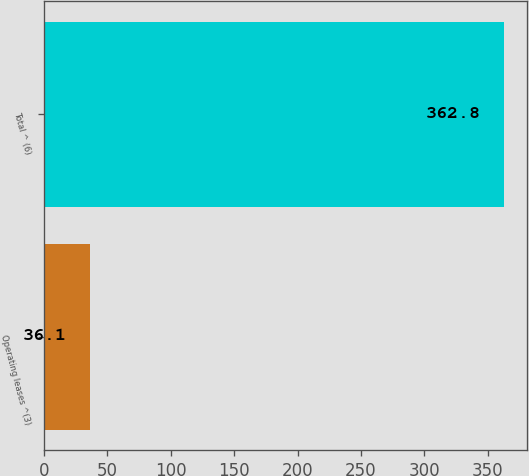Convert chart. <chart><loc_0><loc_0><loc_500><loc_500><bar_chart><fcel>Operating leases ^(3)<fcel>Total ^ (6)<nl><fcel>36.1<fcel>362.8<nl></chart> 